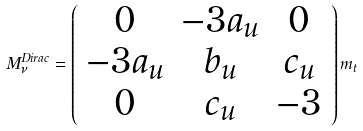Convert formula to latex. <formula><loc_0><loc_0><loc_500><loc_500>M _ { \nu } ^ { D i r a c } = \left ( \begin{array} { c c c } 0 & - 3 a _ { u } & 0 \\ - 3 a _ { u } & b _ { u } & c _ { u } \\ 0 & c _ { u } & - 3 \end{array} \right ) m _ { t }</formula> 